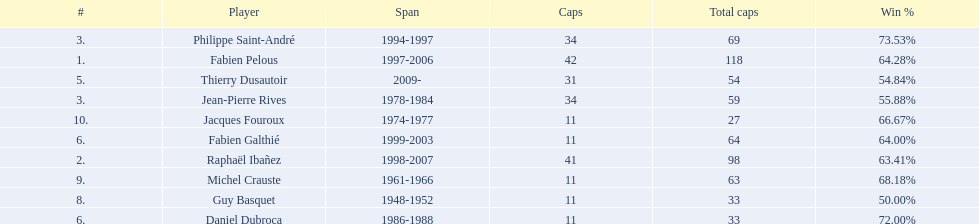How long did michel crauste serve as captain? 1961-1966. 